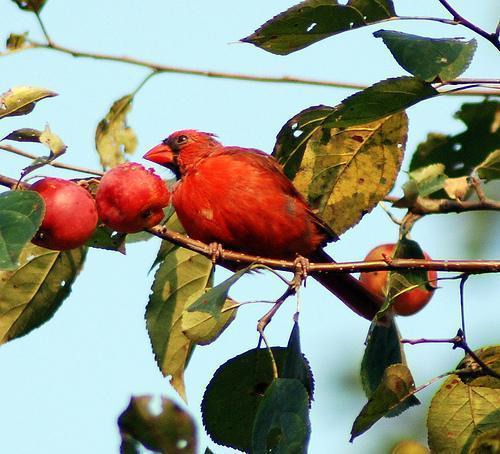How many apples can be seen?
Give a very brief answer. 2. How many laptops are on the table?
Give a very brief answer. 0. 